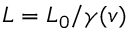<formula> <loc_0><loc_0><loc_500><loc_500>L = L _ { 0 } / \gamma ( v )</formula> 